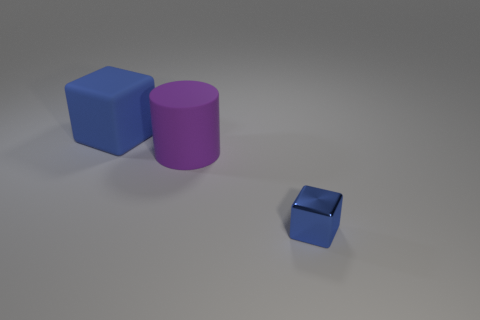Add 3 large purple rubber objects. How many objects exist? 6 Subtract all cylinders. How many objects are left? 2 Subtract all rubber things. Subtract all tiny yellow metallic objects. How many objects are left? 1 Add 3 blue rubber blocks. How many blue rubber blocks are left? 4 Add 2 matte things. How many matte things exist? 4 Subtract 0 cyan balls. How many objects are left? 3 